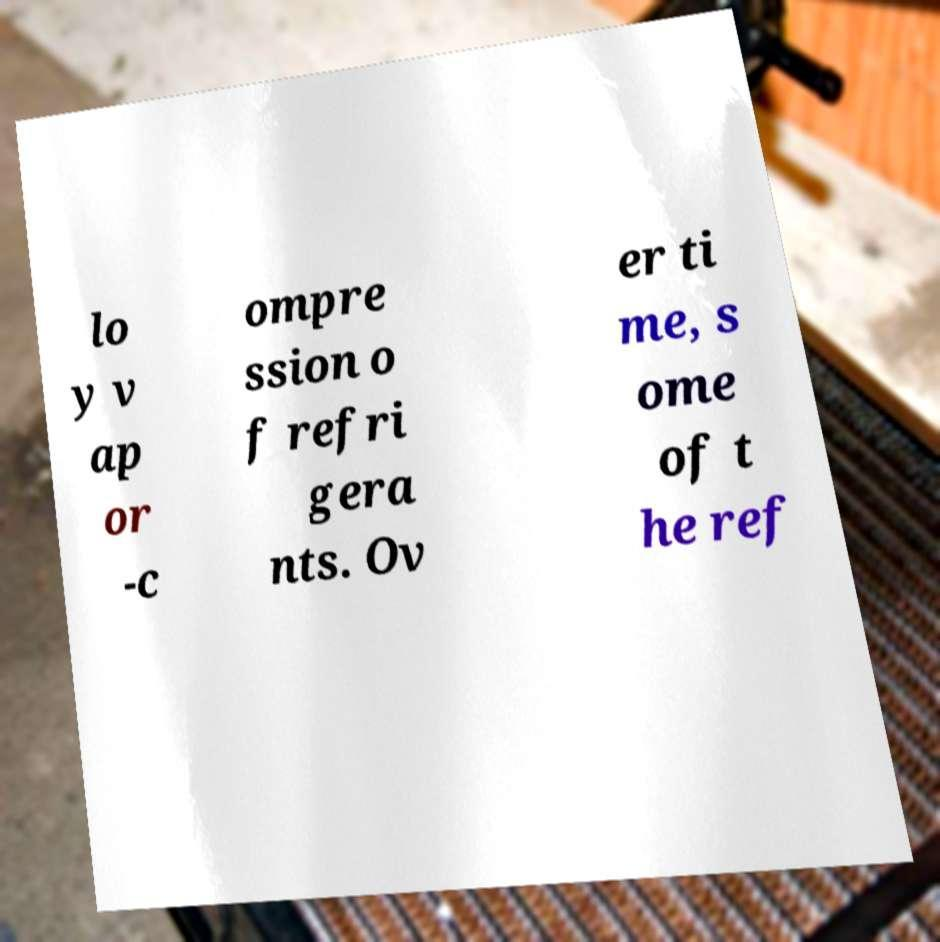Could you extract and type out the text from this image? lo y v ap or -c ompre ssion o f refri gera nts. Ov er ti me, s ome of t he ref 